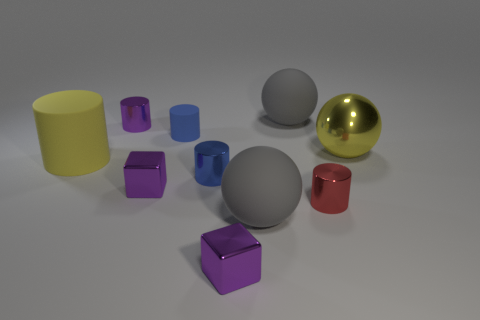Do the big metal object and the large matte cylinder have the same color?
Provide a succinct answer. Yes. What is the material of the other yellow object that is the same shape as the small matte thing?
Make the answer very short. Rubber. What number of shiny objects have the same size as the yellow matte cylinder?
Your answer should be compact. 1. There is a small matte object; what shape is it?
Ensure brevity in your answer.  Cylinder. There is a rubber object that is both behind the red object and in front of the large yellow metal ball; what size is it?
Ensure brevity in your answer.  Large. What is the blue cylinder that is in front of the big yellow rubber cylinder made of?
Your response must be concise. Metal. There is a large metal ball; does it have the same color as the matte cylinder in front of the yellow sphere?
Offer a very short reply. Yes. How many things are big gray balls behind the small red thing or shiny cylinders in front of the purple cylinder?
Your answer should be compact. 3. What color is the thing that is both right of the blue shiny cylinder and behind the big yellow ball?
Keep it short and to the point. Gray. Are there more purple metallic objects than small blue matte things?
Keep it short and to the point. Yes. 